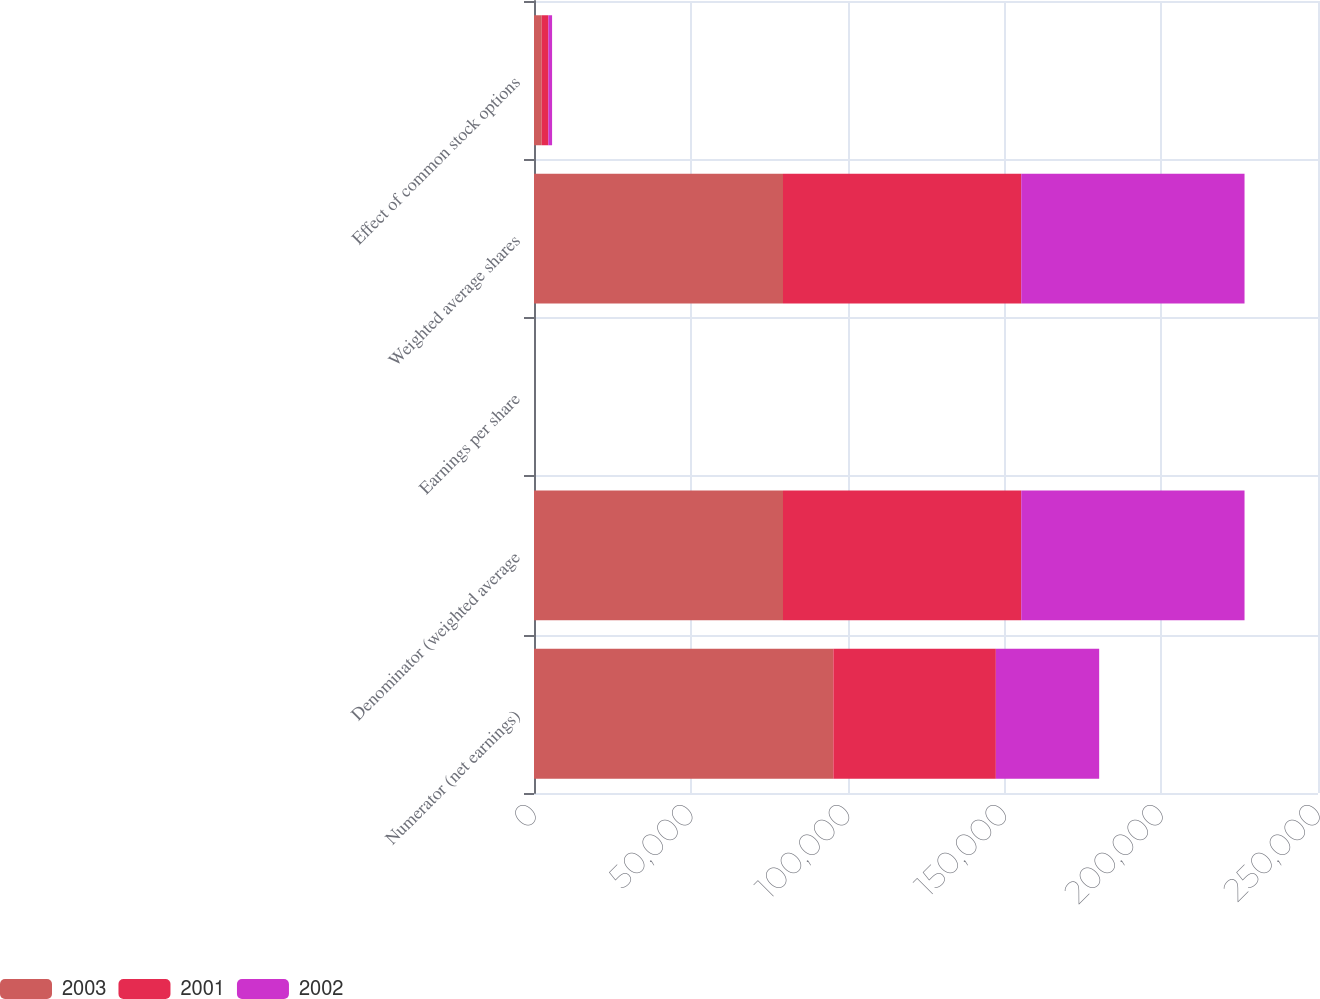Convert chart. <chart><loc_0><loc_0><loc_500><loc_500><stacked_bar_chart><ecel><fcel>Numerator (net earnings)<fcel>Denominator (weighted average<fcel>Earnings per share<fcel>Weighted average shares<fcel>Effect of common stock options<nl><fcel>2003<fcel>95459<fcel>79400<fcel>1.2<fcel>79400<fcel>2454<nl><fcel>2001<fcel>51816<fcel>75968<fcel>0.68<fcel>75968<fcel>2117<nl><fcel>2002<fcel>32945<fcel>71204<fcel>0.46<fcel>71204<fcel>1194<nl></chart> 